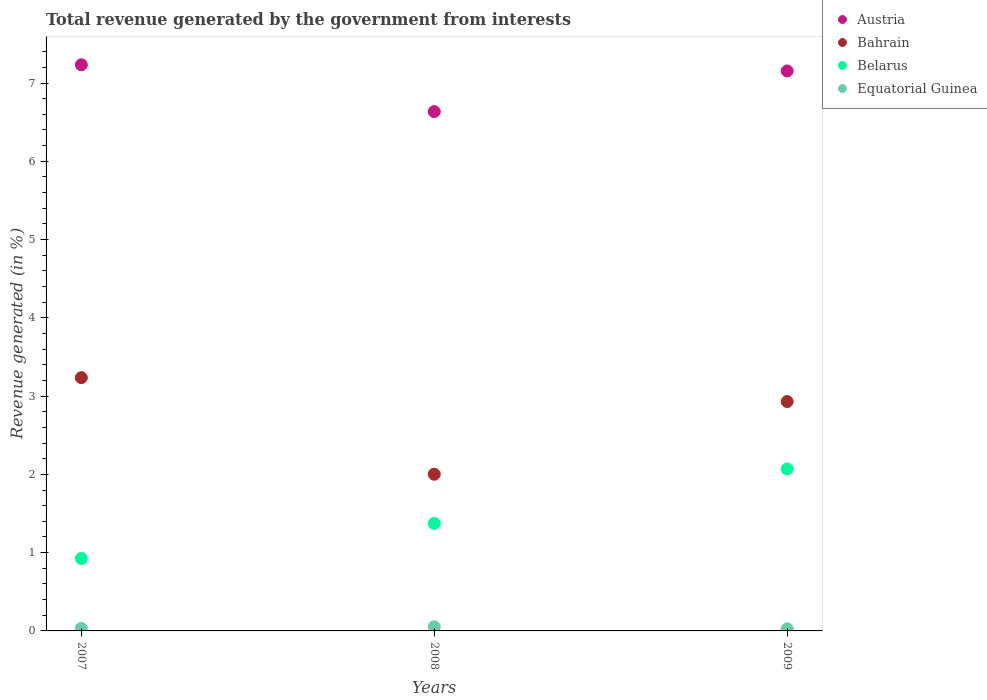How many different coloured dotlines are there?
Give a very brief answer. 4. What is the total revenue generated in Austria in 2009?
Provide a short and direct response. 7.15. Across all years, what is the maximum total revenue generated in Bahrain?
Provide a succinct answer. 3.24. Across all years, what is the minimum total revenue generated in Bahrain?
Your answer should be very brief. 2. In which year was the total revenue generated in Belarus maximum?
Your answer should be very brief. 2009. What is the total total revenue generated in Equatorial Guinea in the graph?
Give a very brief answer. 0.11. What is the difference between the total revenue generated in Austria in 2007 and that in 2009?
Your answer should be compact. 0.08. What is the difference between the total revenue generated in Bahrain in 2008 and the total revenue generated in Belarus in 2007?
Provide a short and direct response. 1.08. What is the average total revenue generated in Belarus per year?
Your answer should be compact. 1.46. In the year 2008, what is the difference between the total revenue generated in Equatorial Guinea and total revenue generated in Bahrain?
Make the answer very short. -1.95. What is the ratio of the total revenue generated in Belarus in 2008 to that in 2009?
Provide a succinct answer. 0.66. Is the total revenue generated in Equatorial Guinea in 2008 less than that in 2009?
Your response must be concise. No. Is the difference between the total revenue generated in Equatorial Guinea in 2007 and 2009 greater than the difference between the total revenue generated in Bahrain in 2007 and 2009?
Provide a short and direct response. No. What is the difference between the highest and the second highest total revenue generated in Belarus?
Offer a terse response. 0.7. What is the difference between the highest and the lowest total revenue generated in Austria?
Your answer should be compact. 0.6. In how many years, is the total revenue generated in Belarus greater than the average total revenue generated in Belarus taken over all years?
Offer a very short reply. 1. Is the sum of the total revenue generated in Austria in 2007 and 2008 greater than the maximum total revenue generated in Bahrain across all years?
Your answer should be very brief. Yes. Is it the case that in every year, the sum of the total revenue generated in Bahrain and total revenue generated in Belarus  is greater than the sum of total revenue generated in Austria and total revenue generated in Equatorial Guinea?
Offer a very short reply. No. Is it the case that in every year, the sum of the total revenue generated in Belarus and total revenue generated in Austria  is greater than the total revenue generated in Equatorial Guinea?
Ensure brevity in your answer.  Yes. Does the total revenue generated in Bahrain monotonically increase over the years?
Your response must be concise. No. Is the total revenue generated in Bahrain strictly greater than the total revenue generated in Belarus over the years?
Keep it short and to the point. Yes. How many years are there in the graph?
Your answer should be very brief. 3. What is the difference between two consecutive major ticks on the Y-axis?
Keep it short and to the point. 1. Are the values on the major ticks of Y-axis written in scientific E-notation?
Provide a short and direct response. No. Does the graph contain grids?
Your answer should be compact. No. How many legend labels are there?
Provide a short and direct response. 4. How are the legend labels stacked?
Provide a short and direct response. Vertical. What is the title of the graph?
Your answer should be very brief. Total revenue generated by the government from interests. Does "Sri Lanka" appear as one of the legend labels in the graph?
Your answer should be very brief. No. What is the label or title of the X-axis?
Your answer should be very brief. Years. What is the label or title of the Y-axis?
Give a very brief answer. Revenue generated (in %). What is the Revenue generated (in %) of Austria in 2007?
Your response must be concise. 7.23. What is the Revenue generated (in %) of Bahrain in 2007?
Give a very brief answer. 3.24. What is the Revenue generated (in %) of Belarus in 2007?
Keep it short and to the point. 0.93. What is the Revenue generated (in %) of Equatorial Guinea in 2007?
Your answer should be very brief. 0.03. What is the Revenue generated (in %) of Austria in 2008?
Offer a very short reply. 6.63. What is the Revenue generated (in %) of Bahrain in 2008?
Provide a short and direct response. 2. What is the Revenue generated (in %) of Belarus in 2008?
Ensure brevity in your answer.  1.37. What is the Revenue generated (in %) in Equatorial Guinea in 2008?
Keep it short and to the point. 0.05. What is the Revenue generated (in %) of Austria in 2009?
Your response must be concise. 7.15. What is the Revenue generated (in %) of Bahrain in 2009?
Ensure brevity in your answer.  2.93. What is the Revenue generated (in %) of Belarus in 2009?
Give a very brief answer. 2.07. What is the Revenue generated (in %) in Equatorial Guinea in 2009?
Ensure brevity in your answer.  0.03. Across all years, what is the maximum Revenue generated (in %) of Austria?
Ensure brevity in your answer.  7.23. Across all years, what is the maximum Revenue generated (in %) of Bahrain?
Your answer should be very brief. 3.24. Across all years, what is the maximum Revenue generated (in %) of Belarus?
Provide a short and direct response. 2.07. Across all years, what is the maximum Revenue generated (in %) in Equatorial Guinea?
Ensure brevity in your answer.  0.05. Across all years, what is the minimum Revenue generated (in %) in Austria?
Keep it short and to the point. 6.63. Across all years, what is the minimum Revenue generated (in %) in Bahrain?
Give a very brief answer. 2. Across all years, what is the minimum Revenue generated (in %) of Belarus?
Provide a short and direct response. 0.93. Across all years, what is the minimum Revenue generated (in %) in Equatorial Guinea?
Your response must be concise. 0.03. What is the total Revenue generated (in %) of Austria in the graph?
Your answer should be compact. 21.02. What is the total Revenue generated (in %) in Bahrain in the graph?
Your response must be concise. 8.17. What is the total Revenue generated (in %) in Belarus in the graph?
Your response must be concise. 4.37. What is the total Revenue generated (in %) of Equatorial Guinea in the graph?
Your answer should be compact. 0.11. What is the difference between the Revenue generated (in %) of Austria in 2007 and that in 2008?
Your answer should be very brief. 0.6. What is the difference between the Revenue generated (in %) of Bahrain in 2007 and that in 2008?
Keep it short and to the point. 1.23. What is the difference between the Revenue generated (in %) of Belarus in 2007 and that in 2008?
Your answer should be compact. -0.45. What is the difference between the Revenue generated (in %) of Equatorial Guinea in 2007 and that in 2008?
Your answer should be compact. -0.02. What is the difference between the Revenue generated (in %) of Austria in 2007 and that in 2009?
Your response must be concise. 0.08. What is the difference between the Revenue generated (in %) in Bahrain in 2007 and that in 2009?
Your answer should be very brief. 0.31. What is the difference between the Revenue generated (in %) in Belarus in 2007 and that in 2009?
Ensure brevity in your answer.  -1.14. What is the difference between the Revenue generated (in %) in Equatorial Guinea in 2007 and that in 2009?
Your response must be concise. 0.01. What is the difference between the Revenue generated (in %) in Austria in 2008 and that in 2009?
Give a very brief answer. -0.52. What is the difference between the Revenue generated (in %) in Bahrain in 2008 and that in 2009?
Offer a very short reply. -0.93. What is the difference between the Revenue generated (in %) in Belarus in 2008 and that in 2009?
Make the answer very short. -0.7. What is the difference between the Revenue generated (in %) of Equatorial Guinea in 2008 and that in 2009?
Your answer should be compact. 0.03. What is the difference between the Revenue generated (in %) of Austria in 2007 and the Revenue generated (in %) of Bahrain in 2008?
Your answer should be compact. 5.23. What is the difference between the Revenue generated (in %) of Austria in 2007 and the Revenue generated (in %) of Belarus in 2008?
Your answer should be very brief. 5.86. What is the difference between the Revenue generated (in %) in Austria in 2007 and the Revenue generated (in %) in Equatorial Guinea in 2008?
Ensure brevity in your answer.  7.18. What is the difference between the Revenue generated (in %) of Bahrain in 2007 and the Revenue generated (in %) of Belarus in 2008?
Make the answer very short. 1.86. What is the difference between the Revenue generated (in %) of Bahrain in 2007 and the Revenue generated (in %) of Equatorial Guinea in 2008?
Offer a very short reply. 3.18. What is the difference between the Revenue generated (in %) of Belarus in 2007 and the Revenue generated (in %) of Equatorial Guinea in 2008?
Your answer should be very brief. 0.87. What is the difference between the Revenue generated (in %) in Austria in 2007 and the Revenue generated (in %) in Bahrain in 2009?
Provide a short and direct response. 4.3. What is the difference between the Revenue generated (in %) of Austria in 2007 and the Revenue generated (in %) of Belarus in 2009?
Ensure brevity in your answer.  5.16. What is the difference between the Revenue generated (in %) in Austria in 2007 and the Revenue generated (in %) in Equatorial Guinea in 2009?
Give a very brief answer. 7.21. What is the difference between the Revenue generated (in %) of Bahrain in 2007 and the Revenue generated (in %) of Belarus in 2009?
Your answer should be very brief. 1.17. What is the difference between the Revenue generated (in %) in Bahrain in 2007 and the Revenue generated (in %) in Equatorial Guinea in 2009?
Offer a terse response. 3.21. What is the difference between the Revenue generated (in %) of Belarus in 2007 and the Revenue generated (in %) of Equatorial Guinea in 2009?
Offer a terse response. 0.9. What is the difference between the Revenue generated (in %) in Austria in 2008 and the Revenue generated (in %) in Bahrain in 2009?
Ensure brevity in your answer.  3.7. What is the difference between the Revenue generated (in %) in Austria in 2008 and the Revenue generated (in %) in Belarus in 2009?
Make the answer very short. 4.57. What is the difference between the Revenue generated (in %) in Austria in 2008 and the Revenue generated (in %) in Equatorial Guinea in 2009?
Your answer should be very brief. 6.61. What is the difference between the Revenue generated (in %) of Bahrain in 2008 and the Revenue generated (in %) of Belarus in 2009?
Offer a terse response. -0.07. What is the difference between the Revenue generated (in %) in Bahrain in 2008 and the Revenue generated (in %) in Equatorial Guinea in 2009?
Offer a very short reply. 1.98. What is the difference between the Revenue generated (in %) of Belarus in 2008 and the Revenue generated (in %) of Equatorial Guinea in 2009?
Keep it short and to the point. 1.35. What is the average Revenue generated (in %) of Austria per year?
Your answer should be very brief. 7.01. What is the average Revenue generated (in %) of Bahrain per year?
Offer a very short reply. 2.72. What is the average Revenue generated (in %) of Belarus per year?
Your response must be concise. 1.46. What is the average Revenue generated (in %) of Equatorial Guinea per year?
Offer a terse response. 0.04. In the year 2007, what is the difference between the Revenue generated (in %) in Austria and Revenue generated (in %) in Bahrain?
Offer a very short reply. 4. In the year 2007, what is the difference between the Revenue generated (in %) of Austria and Revenue generated (in %) of Belarus?
Your response must be concise. 6.31. In the year 2007, what is the difference between the Revenue generated (in %) in Bahrain and Revenue generated (in %) in Belarus?
Ensure brevity in your answer.  2.31. In the year 2007, what is the difference between the Revenue generated (in %) of Bahrain and Revenue generated (in %) of Equatorial Guinea?
Make the answer very short. 3.2. In the year 2007, what is the difference between the Revenue generated (in %) of Belarus and Revenue generated (in %) of Equatorial Guinea?
Offer a very short reply. 0.89. In the year 2008, what is the difference between the Revenue generated (in %) of Austria and Revenue generated (in %) of Bahrain?
Provide a short and direct response. 4.63. In the year 2008, what is the difference between the Revenue generated (in %) in Austria and Revenue generated (in %) in Belarus?
Provide a succinct answer. 5.26. In the year 2008, what is the difference between the Revenue generated (in %) in Austria and Revenue generated (in %) in Equatorial Guinea?
Make the answer very short. 6.58. In the year 2008, what is the difference between the Revenue generated (in %) in Bahrain and Revenue generated (in %) in Belarus?
Your response must be concise. 0.63. In the year 2008, what is the difference between the Revenue generated (in %) in Bahrain and Revenue generated (in %) in Equatorial Guinea?
Provide a succinct answer. 1.95. In the year 2008, what is the difference between the Revenue generated (in %) of Belarus and Revenue generated (in %) of Equatorial Guinea?
Provide a succinct answer. 1.32. In the year 2009, what is the difference between the Revenue generated (in %) of Austria and Revenue generated (in %) of Bahrain?
Offer a very short reply. 4.22. In the year 2009, what is the difference between the Revenue generated (in %) of Austria and Revenue generated (in %) of Belarus?
Keep it short and to the point. 5.08. In the year 2009, what is the difference between the Revenue generated (in %) of Austria and Revenue generated (in %) of Equatorial Guinea?
Ensure brevity in your answer.  7.13. In the year 2009, what is the difference between the Revenue generated (in %) of Bahrain and Revenue generated (in %) of Belarus?
Offer a very short reply. 0.86. In the year 2009, what is the difference between the Revenue generated (in %) in Bahrain and Revenue generated (in %) in Equatorial Guinea?
Offer a very short reply. 2.9. In the year 2009, what is the difference between the Revenue generated (in %) of Belarus and Revenue generated (in %) of Equatorial Guinea?
Ensure brevity in your answer.  2.04. What is the ratio of the Revenue generated (in %) of Austria in 2007 to that in 2008?
Give a very brief answer. 1.09. What is the ratio of the Revenue generated (in %) in Bahrain in 2007 to that in 2008?
Provide a succinct answer. 1.62. What is the ratio of the Revenue generated (in %) of Belarus in 2007 to that in 2008?
Your answer should be very brief. 0.67. What is the ratio of the Revenue generated (in %) of Equatorial Guinea in 2007 to that in 2008?
Offer a terse response. 0.62. What is the ratio of the Revenue generated (in %) of Austria in 2007 to that in 2009?
Your answer should be very brief. 1.01. What is the ratio of the Revenue generated (in %) of Bahrain in 2007 to that in 2009?
Ensure brevity in your answer.  1.1. What is the ratio of the Revenue generated (in %) of Belarus in 2007 to that in 2009?
Offer a very short reply. 0.45. What is the ratio of the Revenue generated (in %) of Equatorial Guinea in 2007 to that in 2009?
Offer a terse response. 1.26. What is the ratio of the Revenue generated (in %) of Austria in 2008 to that in 2009?
Make the answer very short. 0.93. What is the ratio of the Revenue generated (in %) of Bahrain in 2008 to that in 2009?
Your answer should be very brief. 0.68. What is the ratio of the Revenue generated (in %) of Belarus in 2008 to that in 2009?
Offer a very short reply. 0.66. What is the ratio of the Revenue generated (in %) in Equatorial Guinea in 2008 to that in 2009?
Provide a succinct answer. 2.04. What is the difference between the highest and the second highest Revenue generated (in %) of Austria?
Keep it short and to the point. 0.08. What is the difference between the highest and the second highest Revenue generated (in %) in Bahrain?
Your answer should be compact. 0.31. What is the difference between the highest and the second highest Revenue generated (in %) in Belarus?
Keep it short and to the point. 0.7. What is the difference between the highest and the second highest Revenue generated (in %) in Equatorial Guinea?
Your response must be concise. 0.02. What is the difference between the highest and the lowest Revenue generated (in %) in Austria?
Your response must be concise. 0.6. What is the difference between the highest and the lowest Revenue generated (in %) in Bahrain?
Give a very brief answer. 1.23. What is the difference between the highest and the lowest Revenue generated (in %) of Belarus?
Offer a very short reply. 1.14. What is the difference between the highest and the lowest Revenue generated (in %) in Equatorial Guinea?
Offer a terse response. 0.03. 